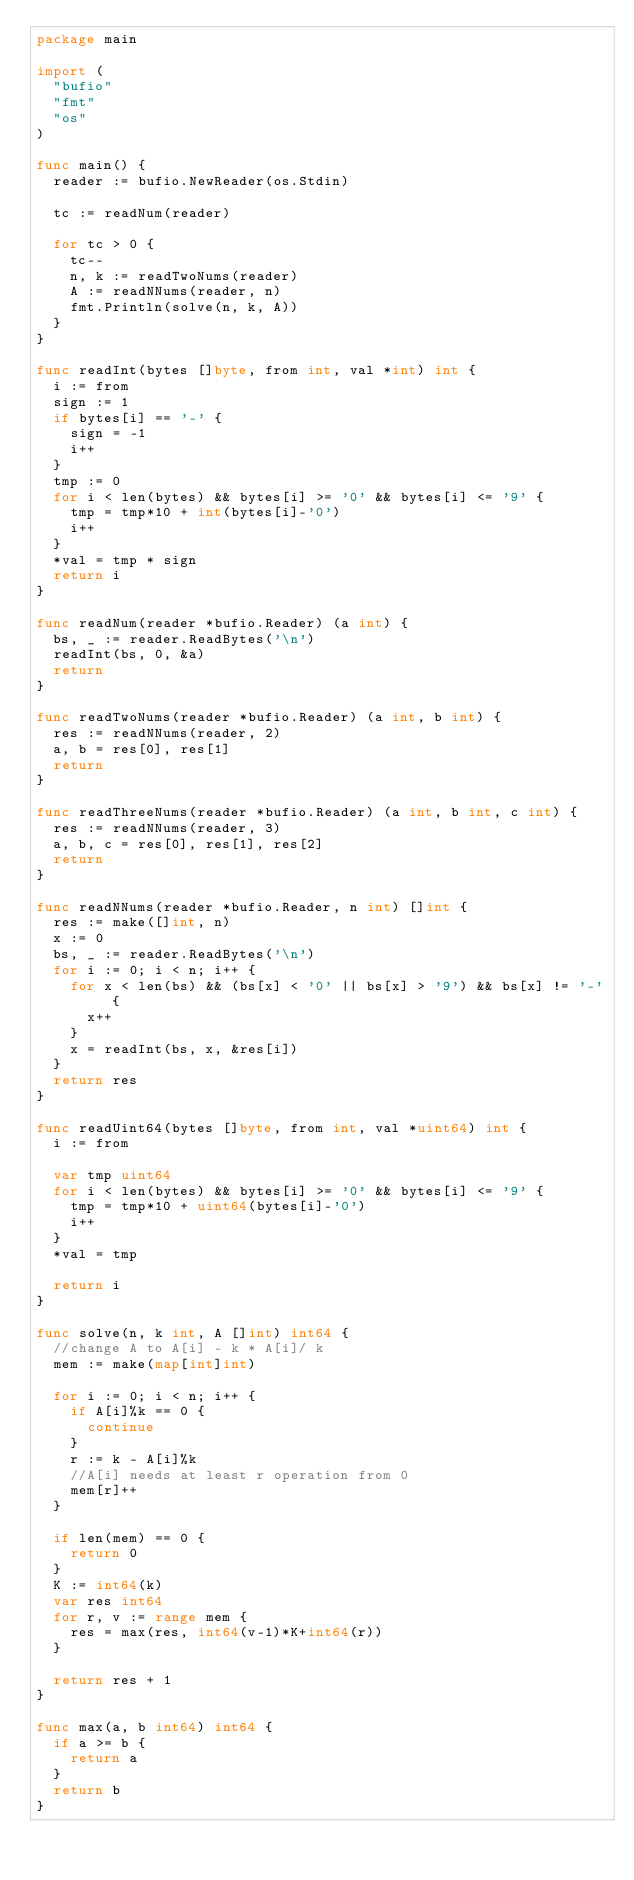<code> <loc_0><loc_0><loc_500><loc_500><_Go_>package main

import (
	"bufio"
	"fmt"
	"os"
)

func main() {
	reader := bufio.NewReader(os.Stdin)

	tc := readNum(reader)

	for tc > 0 {
		tc--
		n, k := readTwoNums(reader)
		A := readNNums(reader, n)
		fmt.Println(solve(n, k, A))
	}
}

func readInt(bytes []byte, from int, val *int) int {
	i := from
	sign := 1
	if bytes[i] == '-' {
		sign = -1
		i++
	}
	tmp := 0
	for i < len(bytes) && bytes[i] >= '0' && bytes[i] <= '9' {
		tmp = tmp*10 + int(bytes[i]-'0')
		i++
	}
	*val = tmp * sign
	return i
}

func readNum(reader *bufio.Reader) (a int) {
	bs, _ := reader.ReadBytes('\n')
	readInt(bs, 0, &a)
	return
}

func readTwoNums(reader *bufio.Reader) (a int, b int) {
	res := readNNums(reader, 2)
	a, b = res[0], res[1]
	return
}

func readThreeNums(reader *bufio.Reader) (a int, b int, c int) {
	res := readNNums(reader, 3)
	a, b, c = res[0], res[1], res[2]
	return
}

func readNNums(reader *bufio.Reader, n int) []int {
	res := make([]int, n)
	x := 0
	bs, _ := reader.ReadBytes('\n')
	for i := 0; i < n; i++ {
		for x < len(bs) && (bs[x] < '0' || bs[x] > '9') && bs[x] != '-' {
			x++
		}
		x = readInt(bs, x, &res[i])
	}
	return res
}

func readUint64(bytes []byte, from int, val *uint64) int {
	i := from

	var tmp uint64
	for i < len(bytes) && bytes[i] >= '0' && bytes[i] <= '9' {
		tmp = tmp*10 + uint64(bytes[i]-'0')
		i++
	}
	*val = tmp

	return i
}

func solve(n, k int, A []int) int64 {
	//change A to A[i] - k * A[i]/ k
	mem := make(map[int]int)

	for i := 0; i < n; i++ {
		if A[i]%k == 0 {
			continue
		}
		r := k - A[i]%k
		//A[i] needs at least r operation from 0
		mem[r]++
	}

	if len(mem) == 0 {
		return 0
	}
	K := int64(k)
	var res int64
	for r, v := range mem {
		res = max(res, int64(v-1)*K+int64(r))
	}

	return res + 1
}

func max(a, b int64) int64 {
	if a >= b {
		return a
	}
	return b
}
</code> 